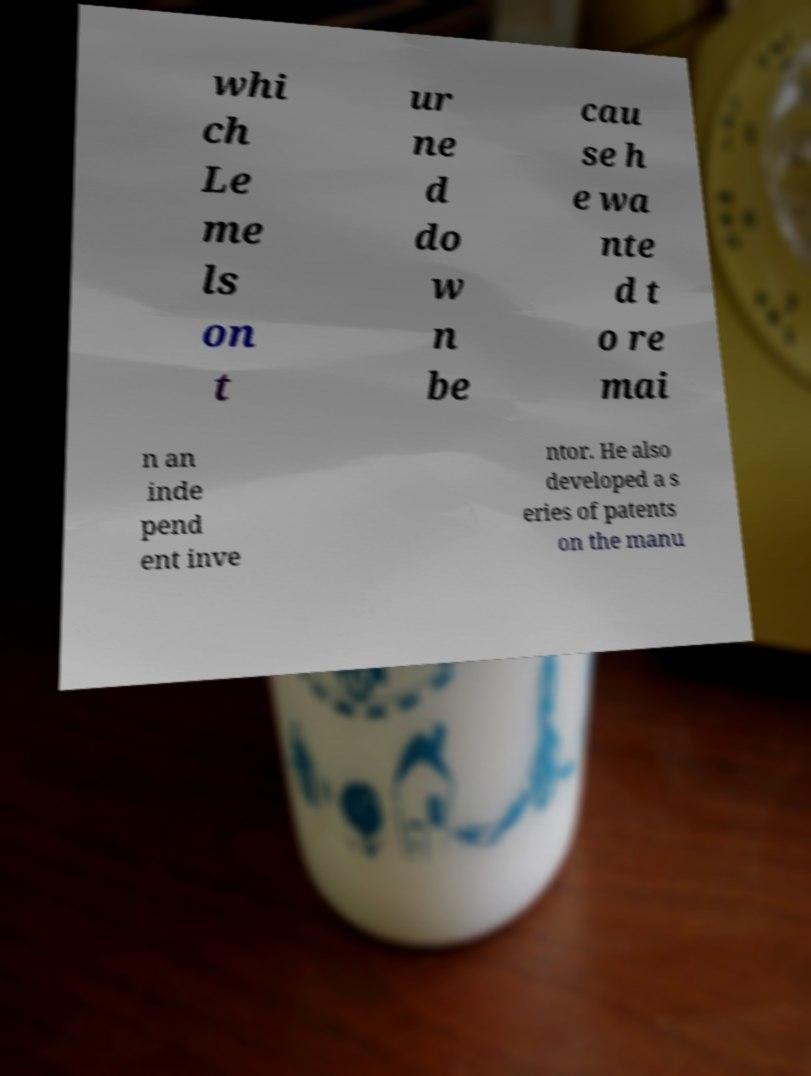There's text embedded in this image that I need extracted. Can you transcribe it verbatim? whi ch Le me ls on t ur ne d do w n be cau se h e wa nte d t o re mai n an inde pend ent inve ntor. He also developed a s eries of patents on the manu 